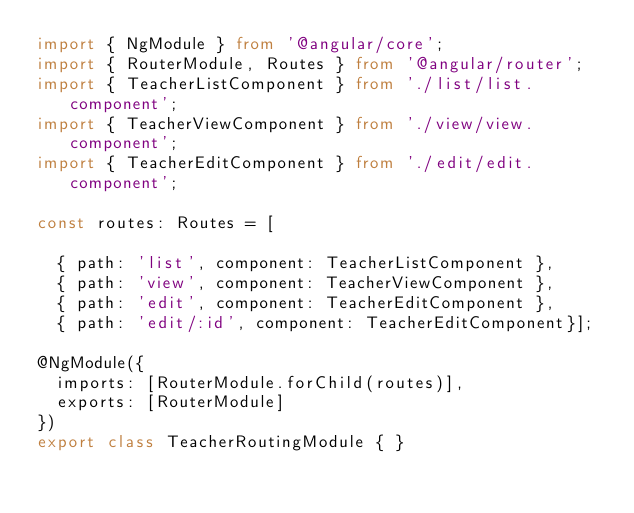Convert code to text. <code><loc_0><loc_0><loc_500><loc_500><_TypeScript_>import { NgModule } from '@angular/core';
import { RouterModule, Routes } from '@angular/router';
import { TeacherListComponent } from './list/list.component';
import { TeacherViewComponent } from './view/view.component';
import { TeacherEditComponent } from './edit/edit.component';

const routes: Routes = [

  { path: 'list', component: TeacherListComponent },
  { path: 'view', component: TeacherViewComponent },
  { path: 'edit', component: TeacherEditComponent },
  { path: 'edit/:id', component: TeacherEditComponent}];

@NgModule({
  imports: [RouterModule.forChild(routes)],
  exports: [RouterModule]
})
export class TeacherRoutingModule { }
</code> 